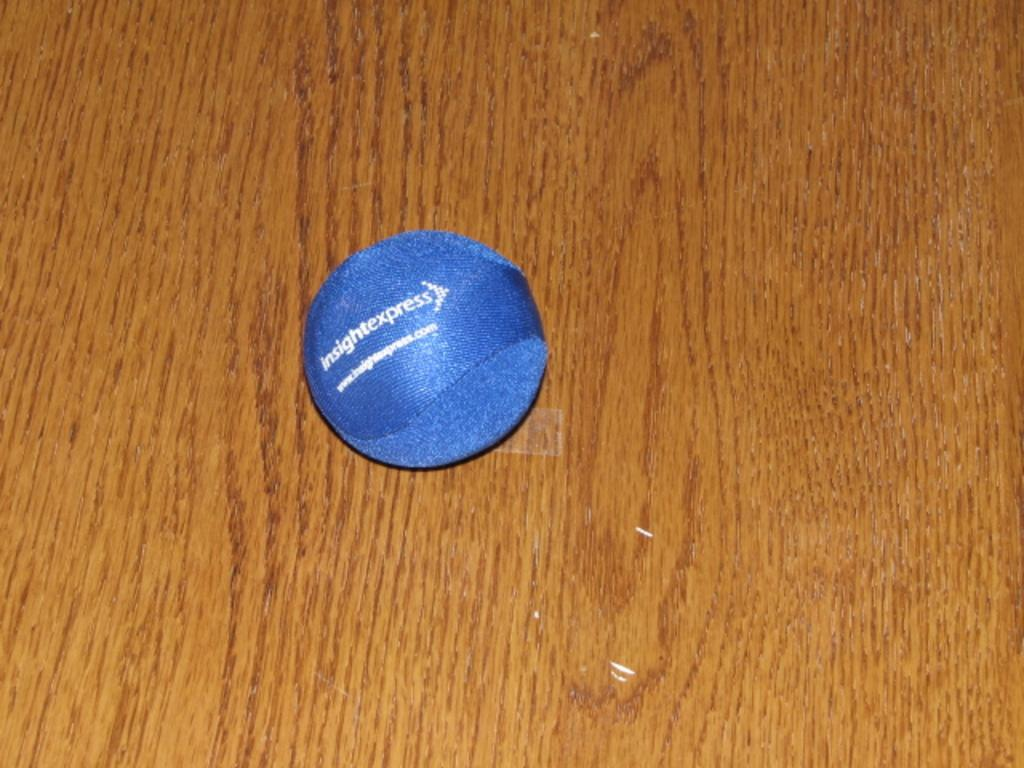What is the color of the ball in the image? The ball in the image is blue. Where is the ball located? The ball is on a wooden table. How many scarves are draped over the blue ball in the image? There are no scarves present in the image; it only features a blue ball on a wooden table. 